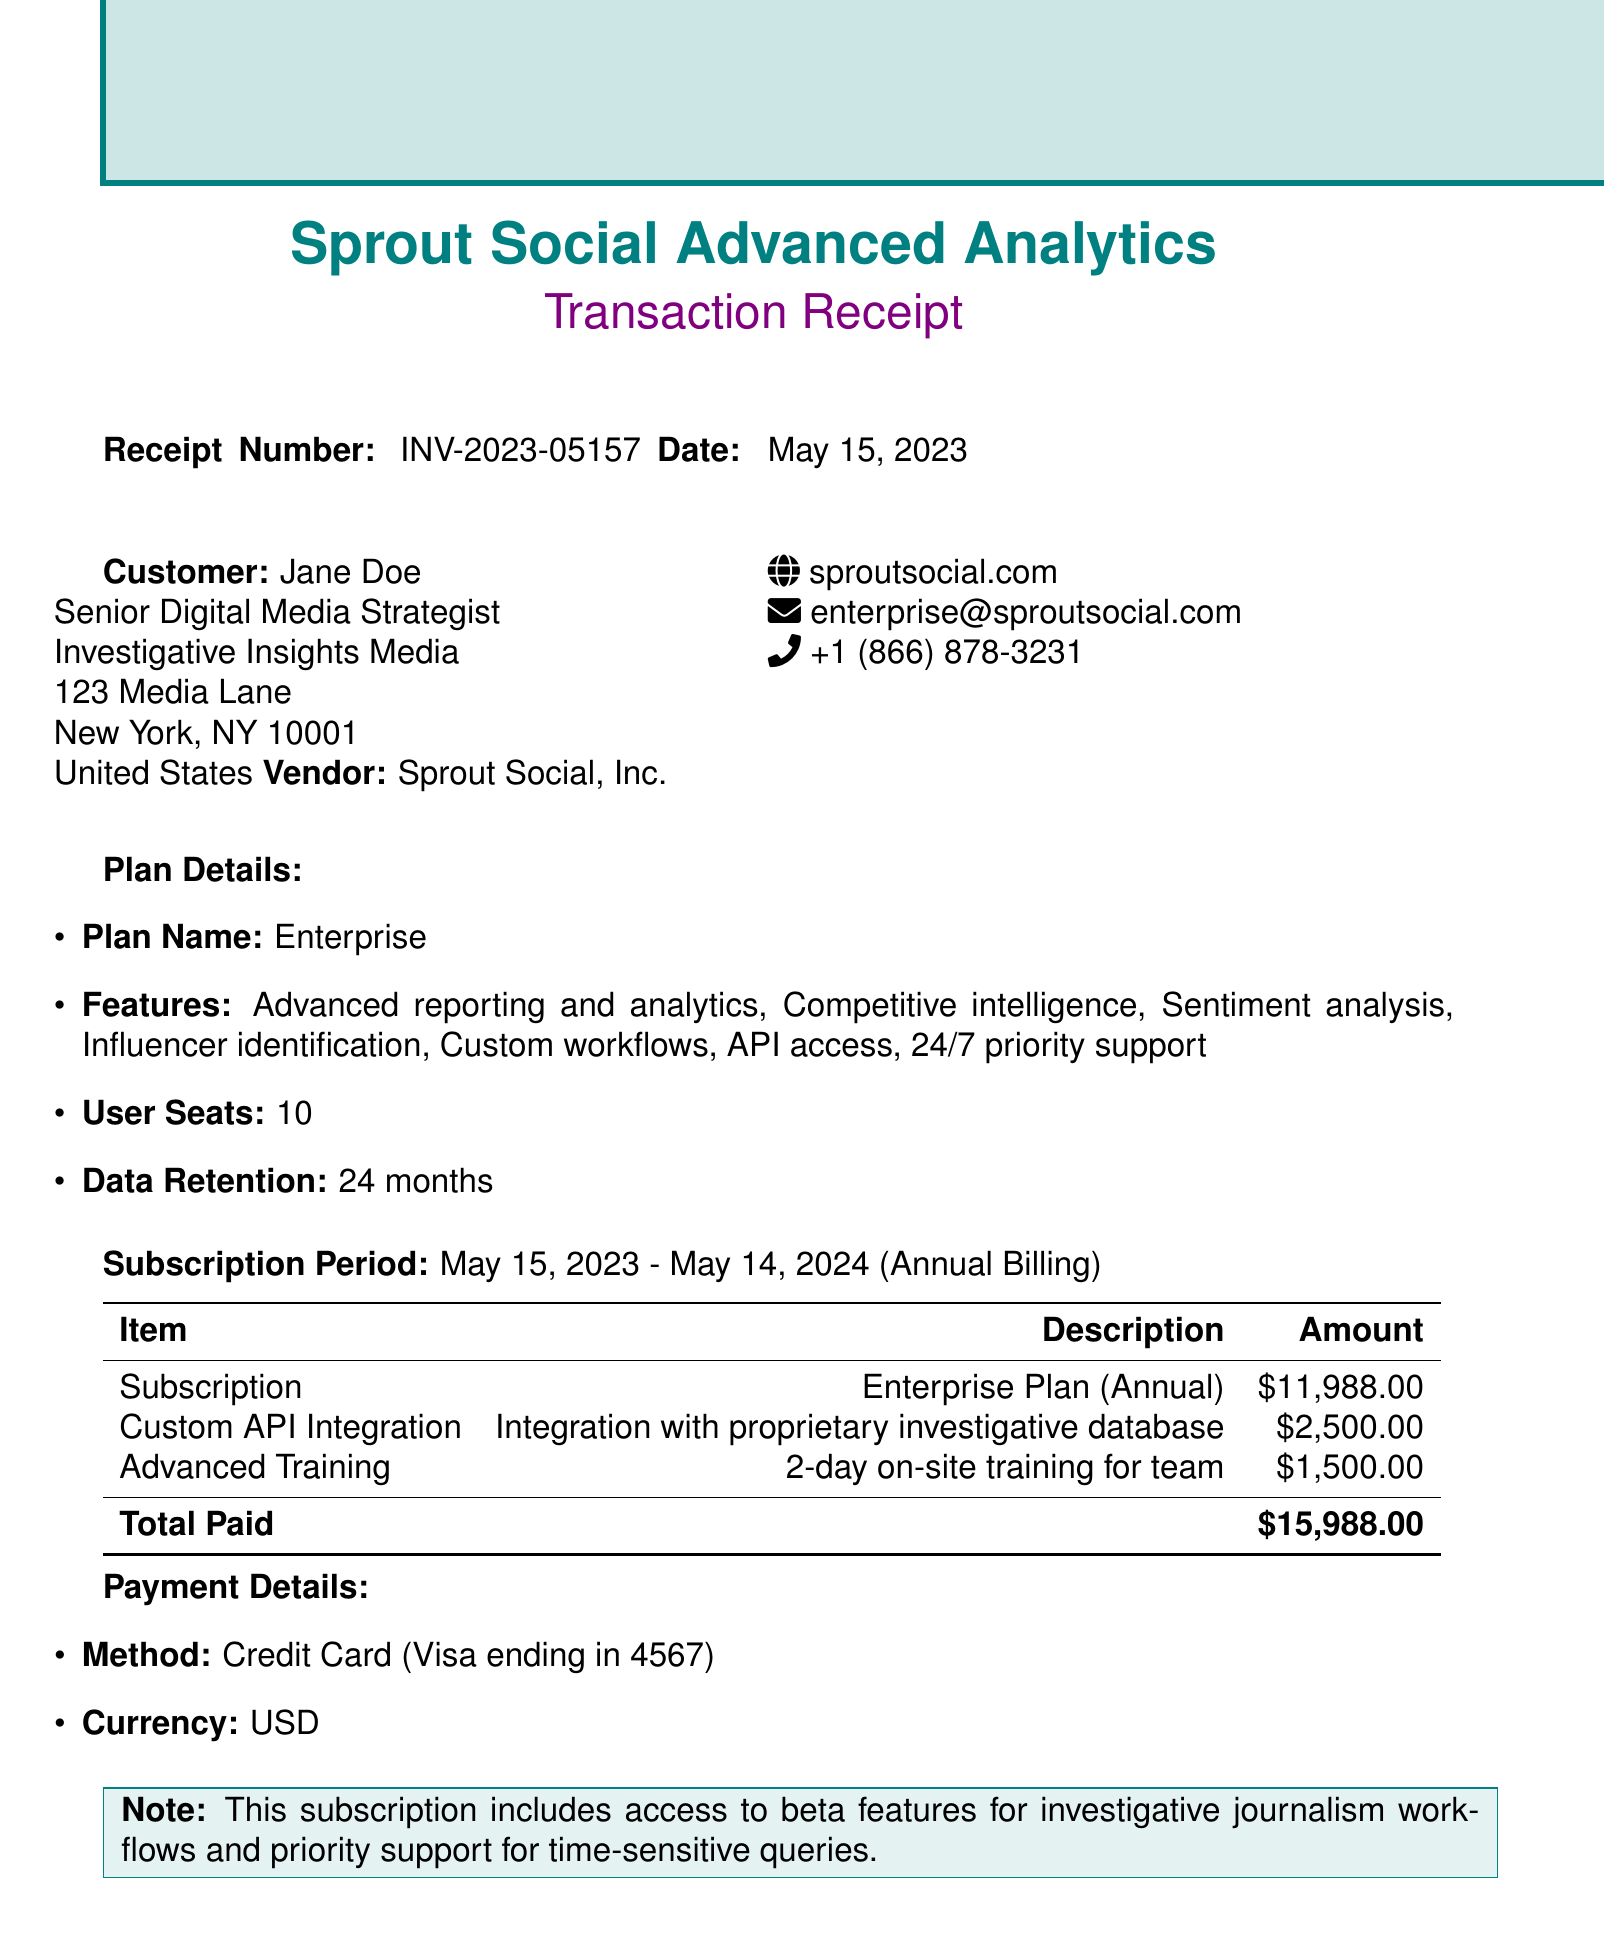What is the receipt number? The receipt number is a unique identifier for the transaction, found in the document.
Answer: INV-2023-05157 Who is the customer? The customer's name is listed in the document, along with their title and company name.
Answer: Jane Doe What is the total amount paid? The total amount paid is the final figure representing the entire cost incurred for the subscription and additional services.
Answer: $15,988.00 What is the subscription period? The subscription period indicates the time frame for which the service is provided and is specified in the document.
Answer: May 15, 2023 - May 14, 2024 How many user seats are included in the plan? The document specifies the number of user seats that come with the subscription plan.
Answer: 10 What features does the plan offer? The features are listed in the plan details section, indicating what functionalities are included with the subscription.
Answer: Advanced reporting and analytics, Competitive intelligence, Sentiment analysis, Influencer identification, Custom workflows, API access, 24/7 priority support Which payment method was used? The payment method indicates how the transaction was processed and is specified in the payment details section of the document.
Answer: Credit Card What additional service has a fee of $2,500? This question asks for specific information about the additional services and their associated fees.
Answer: Custom API Integration What is the vendor's support email? The vendor's support email is provided for customer inquiries and support services in the document.
Answer: enterprise@sproutsocial.com 